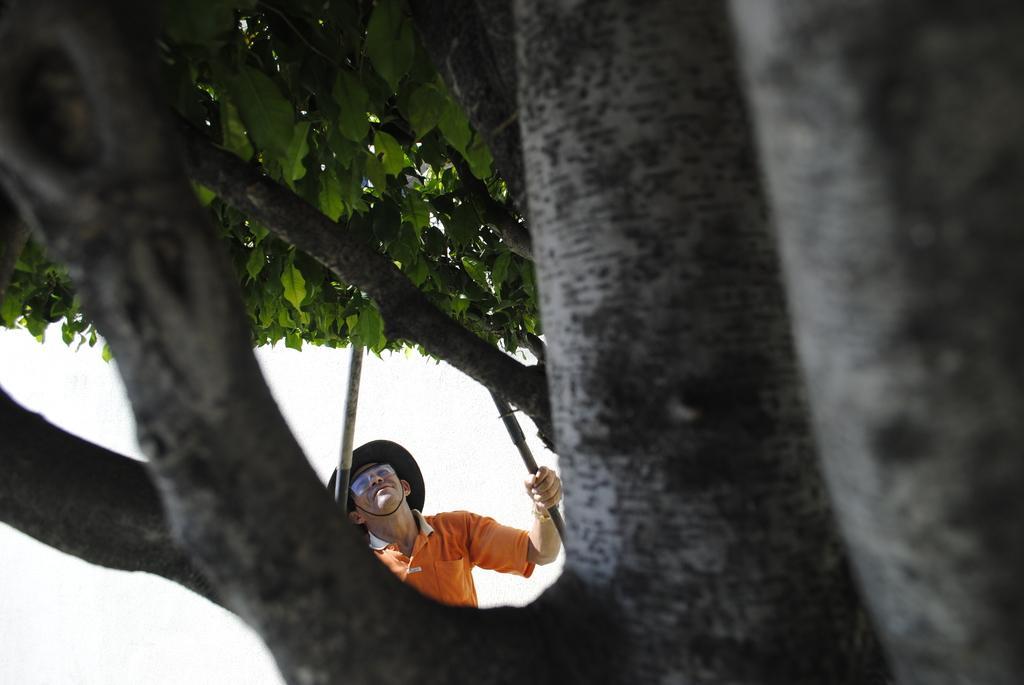In one or two sentences, can you explain what this image depicts? In this image I can see tree trunk, number of green colour leaves and here I can see a man, I can see he is wearing orange colour t shirt and a hat. I can also see he is holding sticks. 